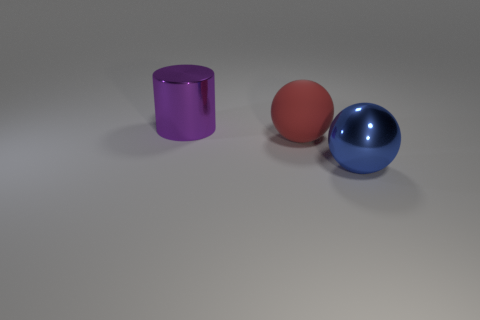Add 1 big rubber objects. How many objects exist? 4 Subtract all cylinders. How many objects are left? 2 Subtract 1 spheres. How many spheres are left? 1 Subtract all brown cylinders. Subtract all yellow balls. How many cylinders are left? 1 Subtract all cyan rubber spheres. Subtract all big balls. How many objects are left? 1 Add 1 big blue balls. How many big blue balls are left? 2 Add 3 red objects. How many red objects exist? 4 Subtract 0 blue blocks. How many objects are left? 3 